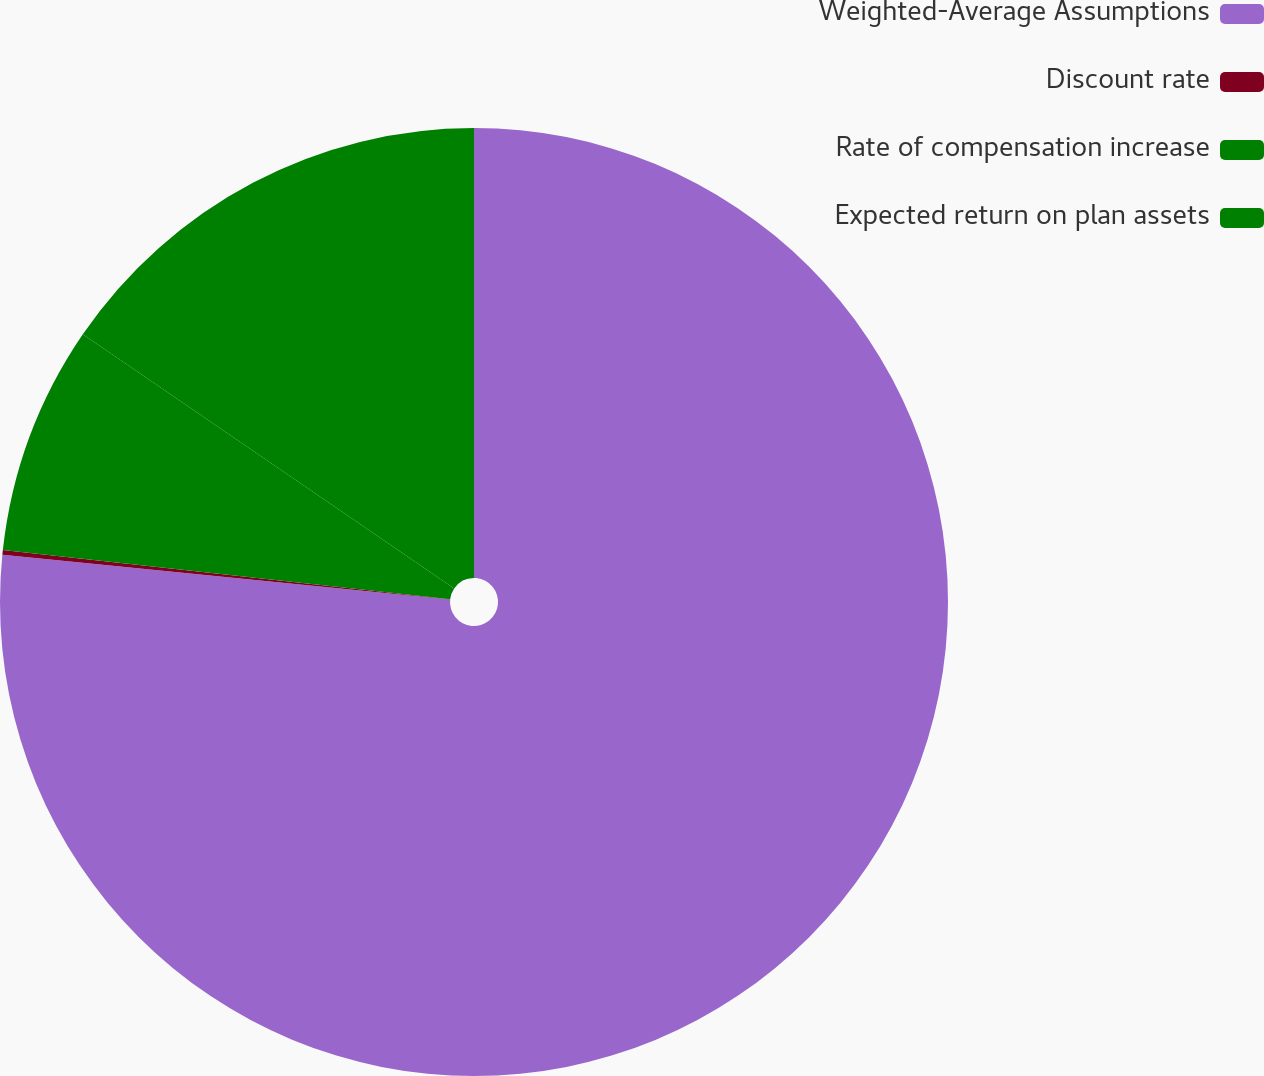Convert chart to OTSL. <chart><loc_0><loc_0><loc_500><loc_500><pie_chart><fcel>Weighted-Average Assumptions<fcel>Discount rate<fcel>Rate of compensation increase<fcel>Expected return on plan assets<nl><fcel>76.59%<fcel>0.16%<fcel>7.8%<fcel>15.45%<nl></chart> 